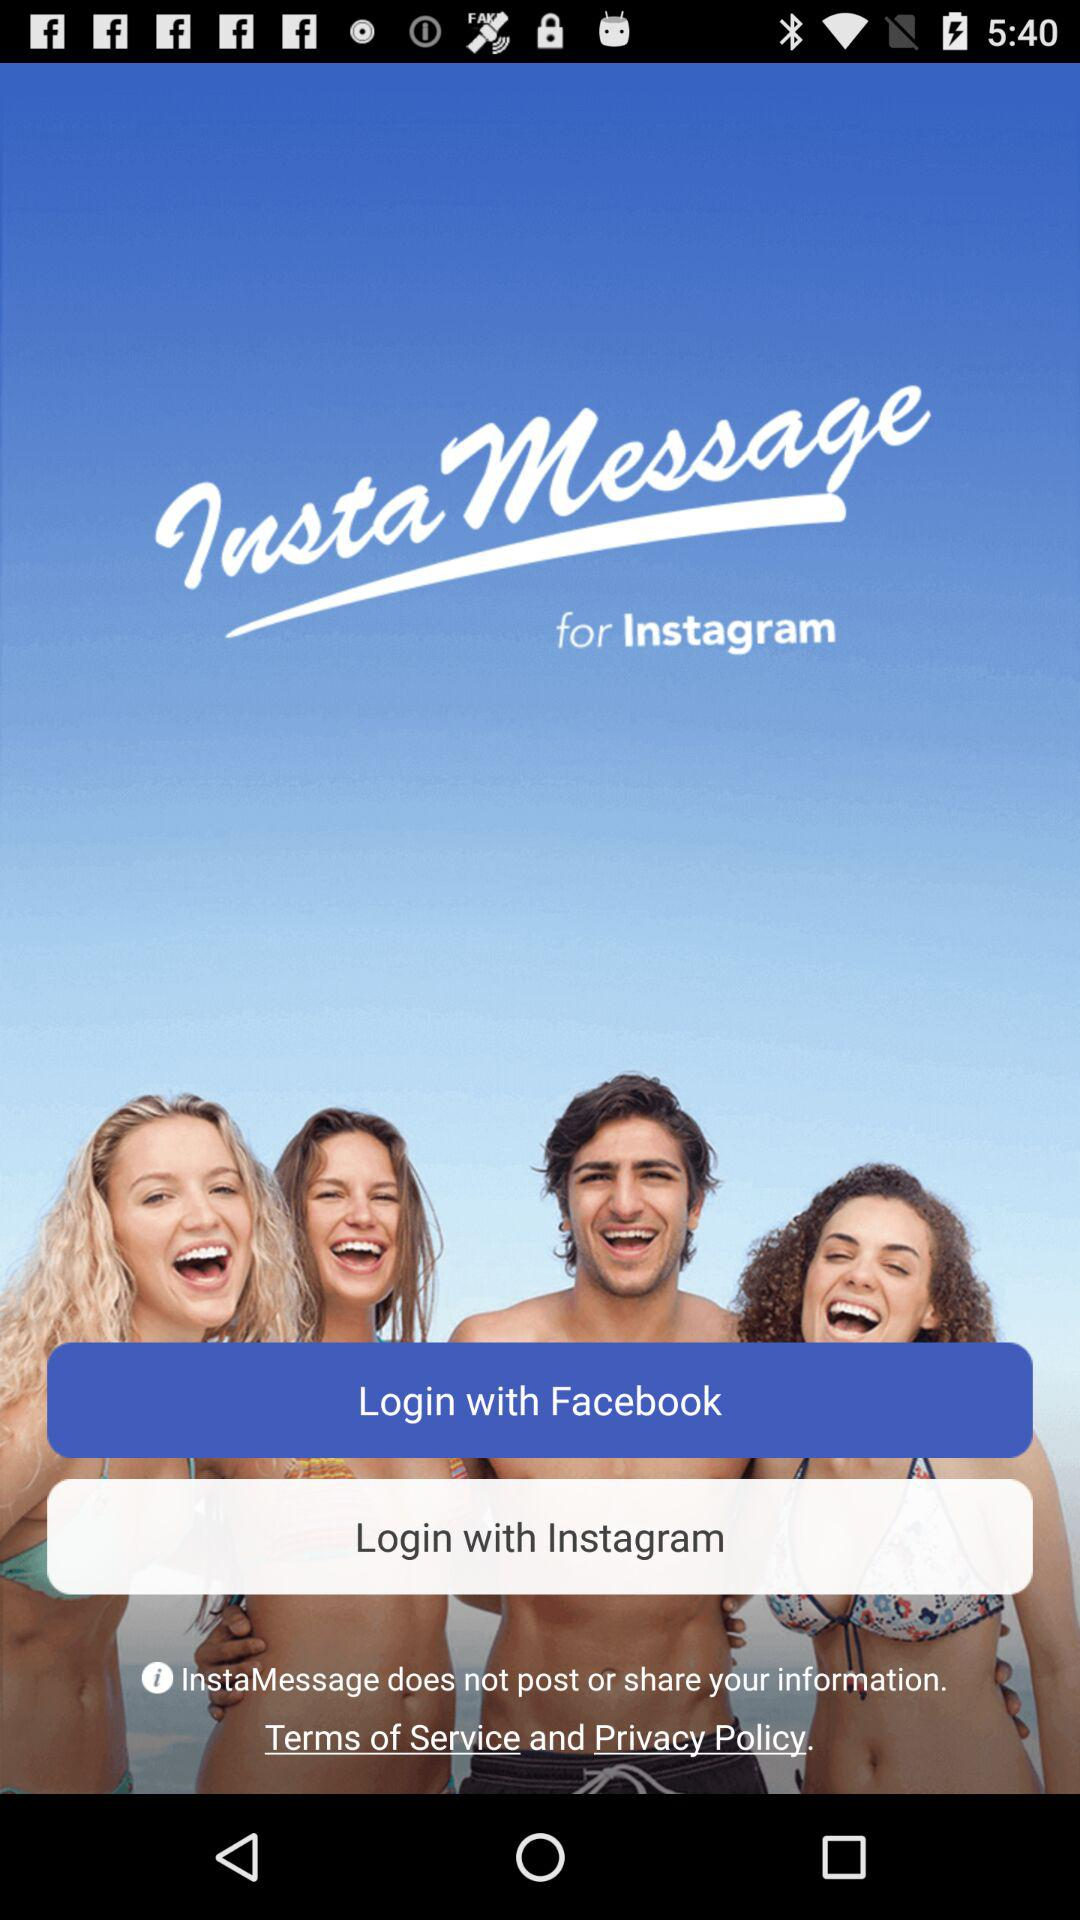What accounts can be used to login? The accounts that can be used to login are "Facebook" and "Instagram". 